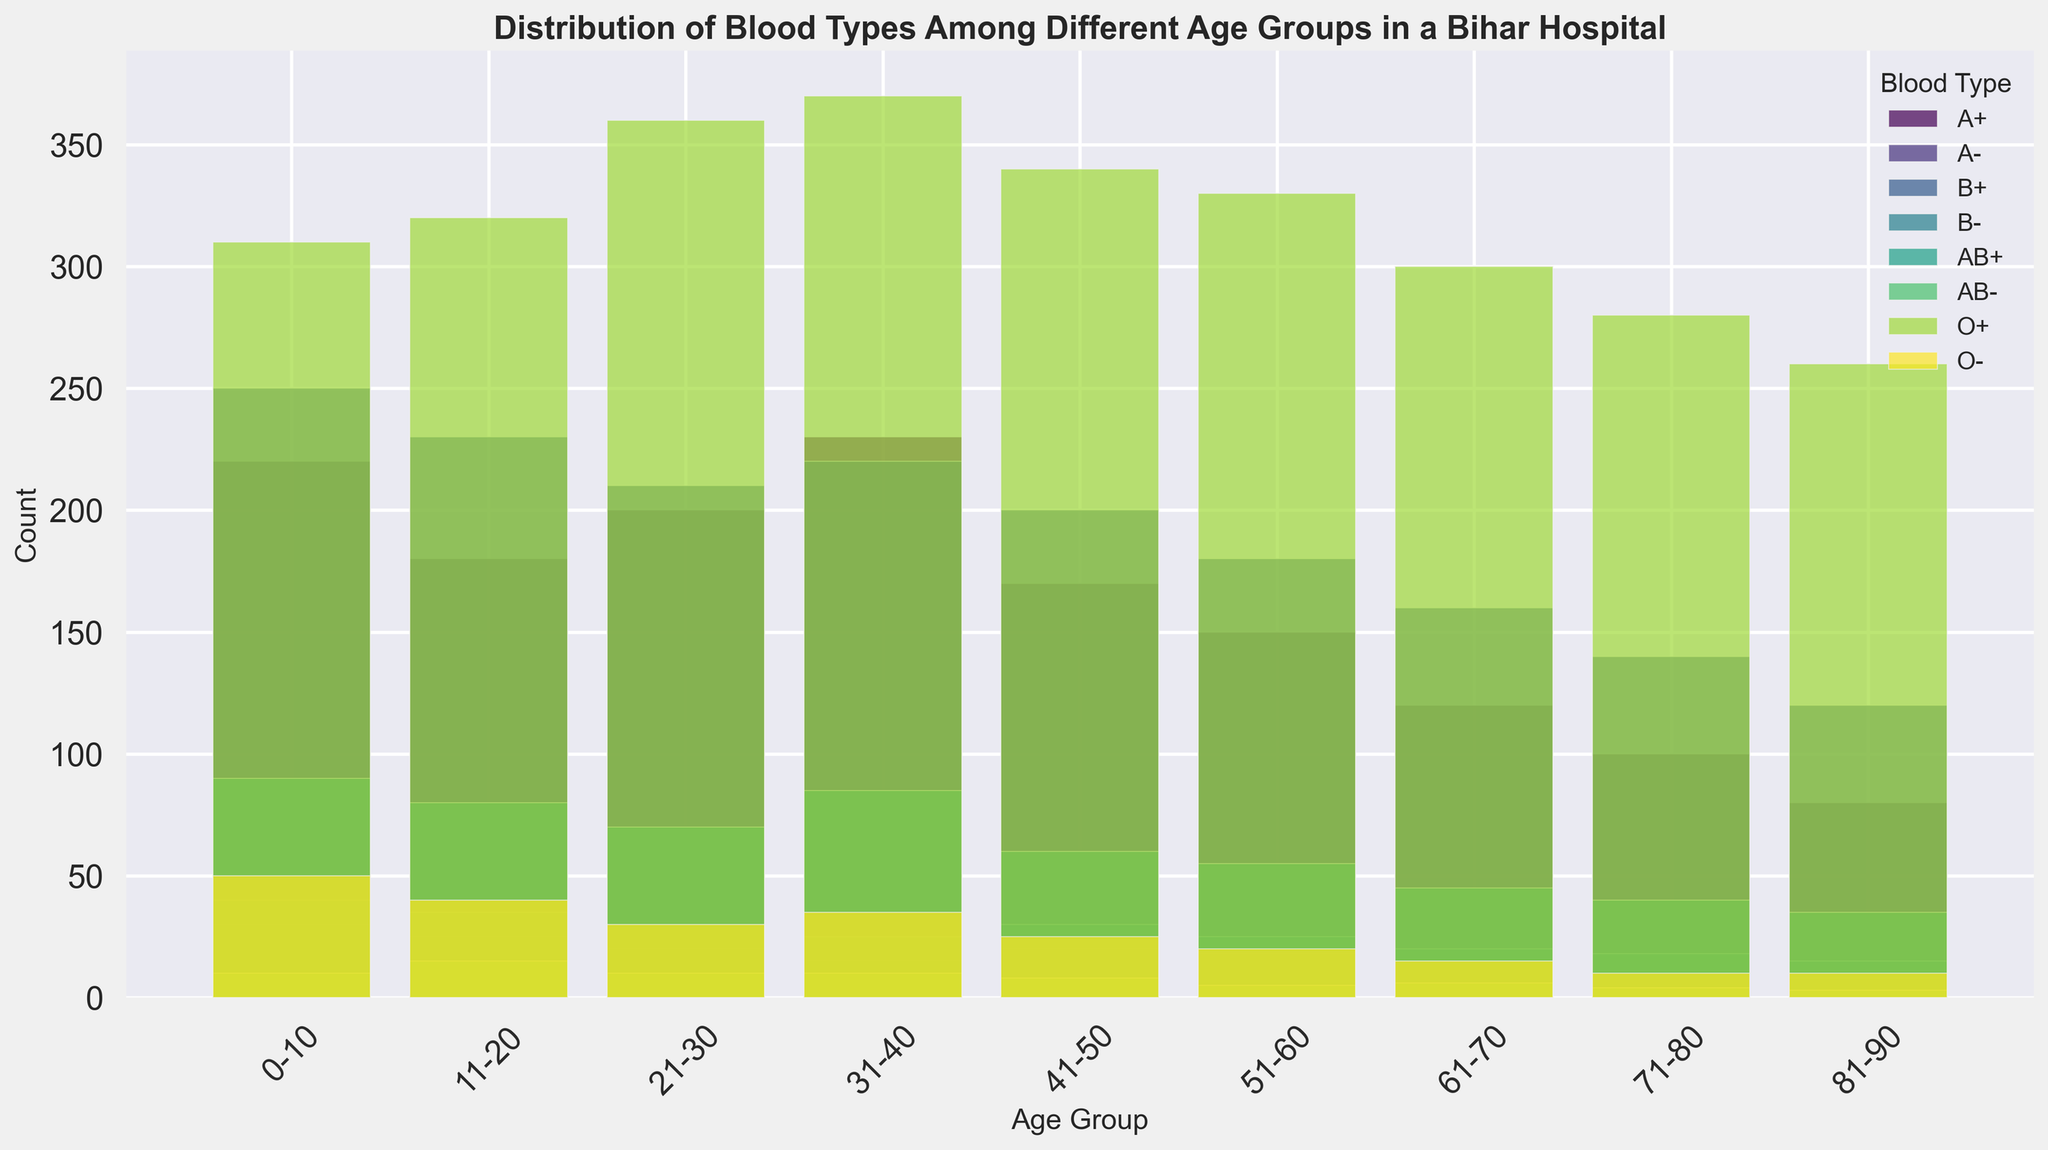Which age group has the highest count for O+ blood type? To determine this, observe the bar height for O+ blood type across all age groups. The highest bar represents the age group with the largest count.
Answer: 31-40 What is the total count of B+ blood type across all age groups? Sum up the counts for B+ blood type from all age groups: 250 + 230 + 210 + 220 + 200 + 180 + 160 + 140 + 120.
Answer: 1710 Which blood type has the lowest count in the age group 51-60? Compare the bar heights for all blood types within the 51-60 age group. The lowest bar corresponds to the blood type with the smallest count.
Answer: AB- How does the count of O+ blood type change from age group 0-10 to age group 81-90? Subtract the count of O+ in age group 81-90 (260) from that in age group 0-10 (310). 310 - 260 = 50. So, the count decreases by 50.
Answer: Decreases by 50 What is the average count of A+ blood type across all age groups? Add up the counts for A+ blood type across all age groups, then divide by the number of age groups (9). (220 + 180 + 200 + 230 + 170 + 150 + 120 + 100 + 80) / 9 = 1611 / 9.
Answer: 179 Which age group has the most diverse distribution of blood types? Look for the age group where the bars for different blood types show the least variation in height, indicating similar counts for all types. The 31-40 age group seems to have relatively balanced heights among the different blood types.
Answer: 31-40 Which blood type shows the most significant overall decline in count as the age group increases? Observe the trend in bar heights for all blood types across increasing age groups. A+ blood type shows a noticeable declining trend.
Answer: A+ Which age group has the least total count of all blood types combined? Sum up the counts for all blood types in each age group, and identify the age group with the smallest total. The 81-90 age group has the smallest combined count by summing up all the counts.
Answer: 81-90 How does the count of AB+ blood type in the age group 31-40 compare to that in the age group 0-10? To find the comparison, subtract the count of AB+ in age group 0-10 (90) from that in age group 31-40 (85). 85 - 90 = -5. This means the count decreases by 5.
Answer: Decreases by 5 Which blood type has the highest combined count among all 9 age groups? Add up the counts for each blood type across all age groups. The blood type with the largest sum is the one with the highest combined count. O+ has the highest combined count when summed across all age groups.
Answer: O+ 